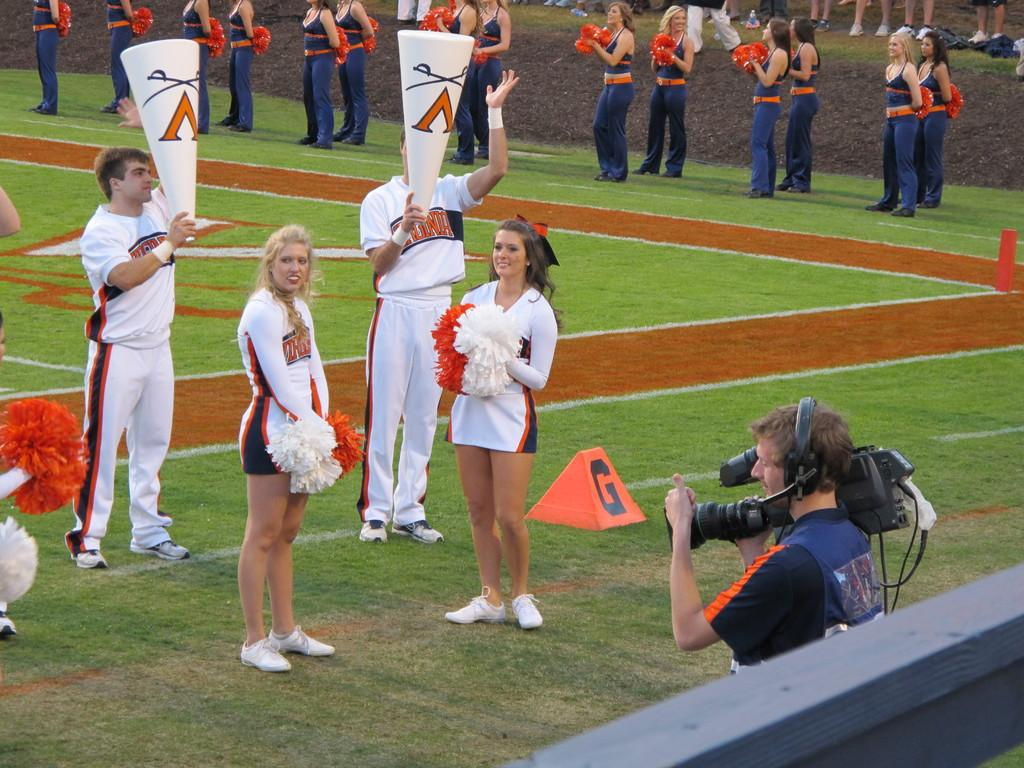<image>
Describe the image concisely. the letter G is on the orange sign next to the cheerleaders 